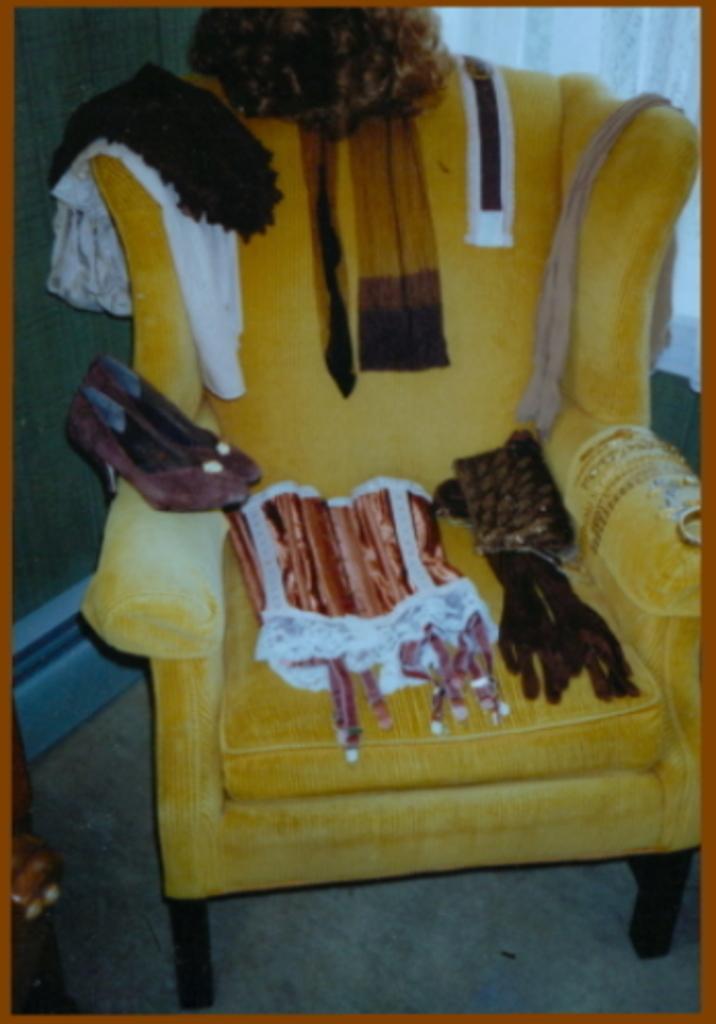Please provide a concise description of this image. In this picture we can see a chair on the floor with footwear, clothes and some objects on it. In the background we can see curtain and the wall. 